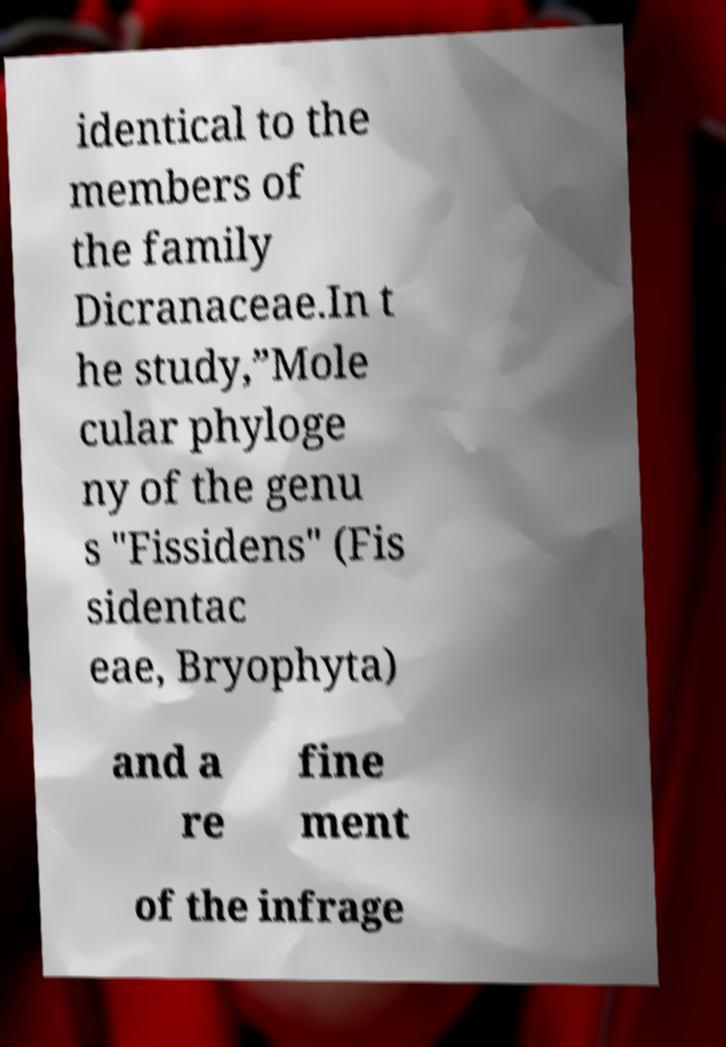Please read and relay the text visible in this image. What does it say? identical to the members of the family Dicranaceae.In t he study,”Mole cular phyloge ny of the genu s "Fissidens" (Fis sidentac eae, Bryophyta) and a re fine ment of the infrage 